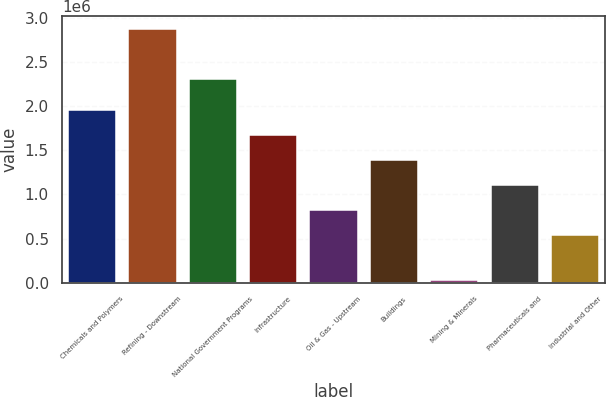<chart> <loc_0><loc_0><loc_500><loc_500><bar_chart><fcel>Chemicals and Polymers<fcel>Refining - Downstream<fcel>National Government Programs<fcel>Infrastructure<fcel>Oil & Gas - Upstream<fcel>Buildings<fcel>Mining & Minerals<fcel>Pharmaceuticals and<fcel>Industrial and Other<nl><fcel>1.96281e+06<fcel>2.87606e+06<fcel>2.31455e+06<fcel>1.67782e+06<fcel>822853<fcel>1.39283e+06<fcel>26161<fcel>1.10784e+06<fcel>537863<nl></chart> 